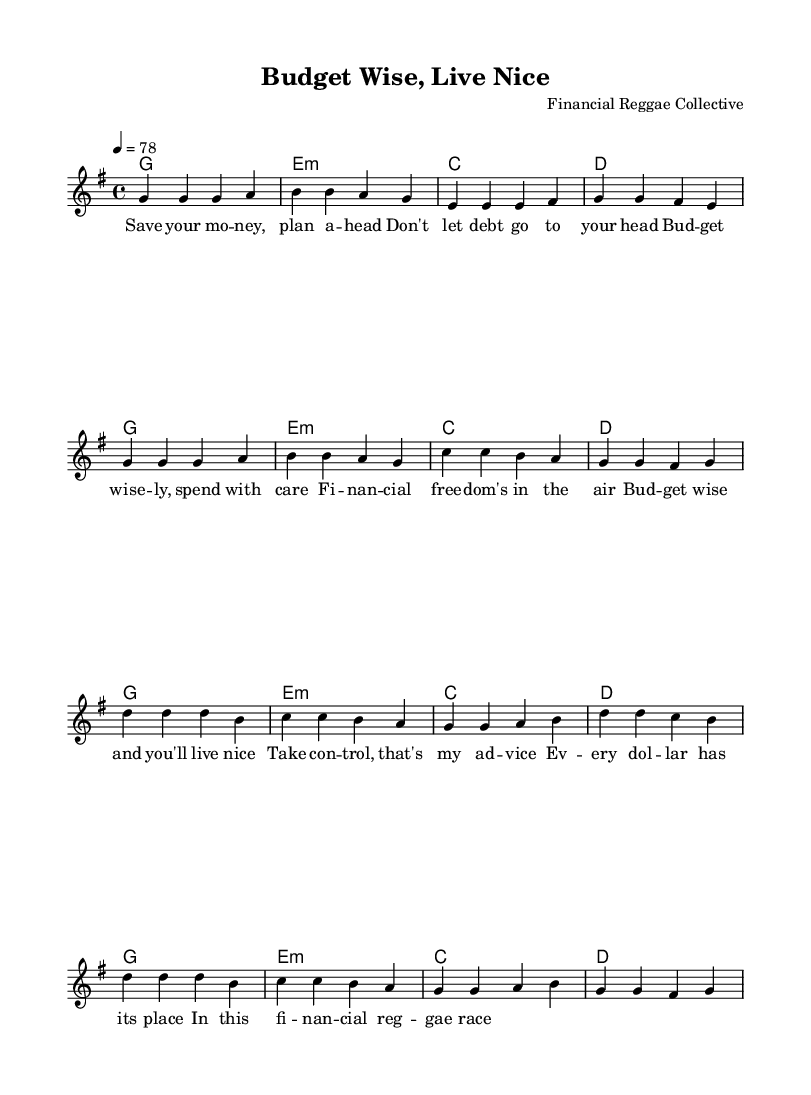What is the key signature of this music? The key signature is G major, which has one sharp (F#). We can identify this by looking at the key signature symbol at the beginning of the staff.
Answer: G major What is the time signature of this music? The time signature is 4/4, indicated by the two numbers at the beginning of the sheet music. The top number (4) represents the number of beats per measure, and the bottom number (4) indicates a quarter note gets one beat.
Answer: 4/4 What is the tempo marking of this music? The tempo marking indicated at the beginning is "4 = 78," meaning there are 78 beats per minute. This marking helps to set the speed of the piece.
Answer: 78 What is the main theme of the lyrics? The lyrics focus on financial responsibility and the importance of budgeting wisely, promoting the message of maintaining control over one's finances. This theme can be derived from the repeated phrases in the verse and chorus sections.
Answer: Financial responsibility What chord follows the melody's first note in the verse? The chord that follows the first note (G) in the verse is G major, as indicated in the chord section right above the melody. This shows that the melody begins on the tonic chord of the key.
Answer: G Which section of the song contains the lyrics about taking control? The section containing the lyrics about taking control is the chorus, where the lines specifically advise on taking control of one's finances. This can be identified by noting the transition from verse lyrics to chorus lyrics.
Answer: Chorus 